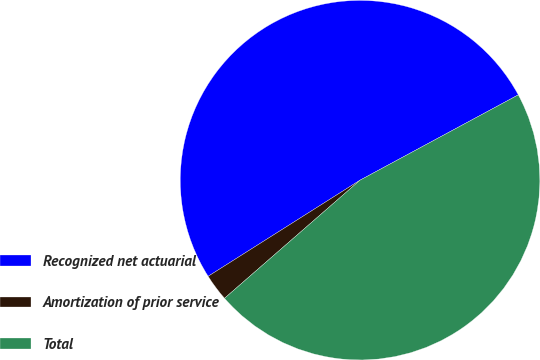Convert chart. <chart><loc_0><loc_0><loc_500><loc_500><pie_chart><fcel>Recognized net actuarial<fcel>Amortization of prior service<fcel>Total<nl><fcel>51.11%<fcel>2.43%<fcel>46.46%<nl></chart> 